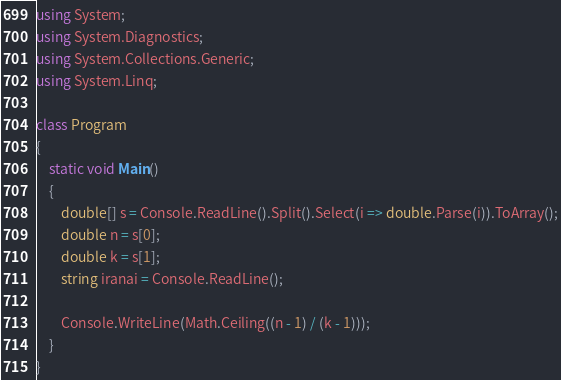<code> <loc_0><loc_0><loc_500><loc_500><_C#_>using System;
using System.Diagnostics;
using System.Collections.Generic;
using System.Linq;

class Program
{
    static void Main()
    {
        double[] s = Console.ReadLine().Split().Select(i => double.Parse(i)).ToArray();
        double n = s[0];
        double k = s[1];
        string iranai = Console.ReadLine();

        Console.WriteLine(Math.Ceiling((n - 1) / (k - 1)));
    }
}</code> 